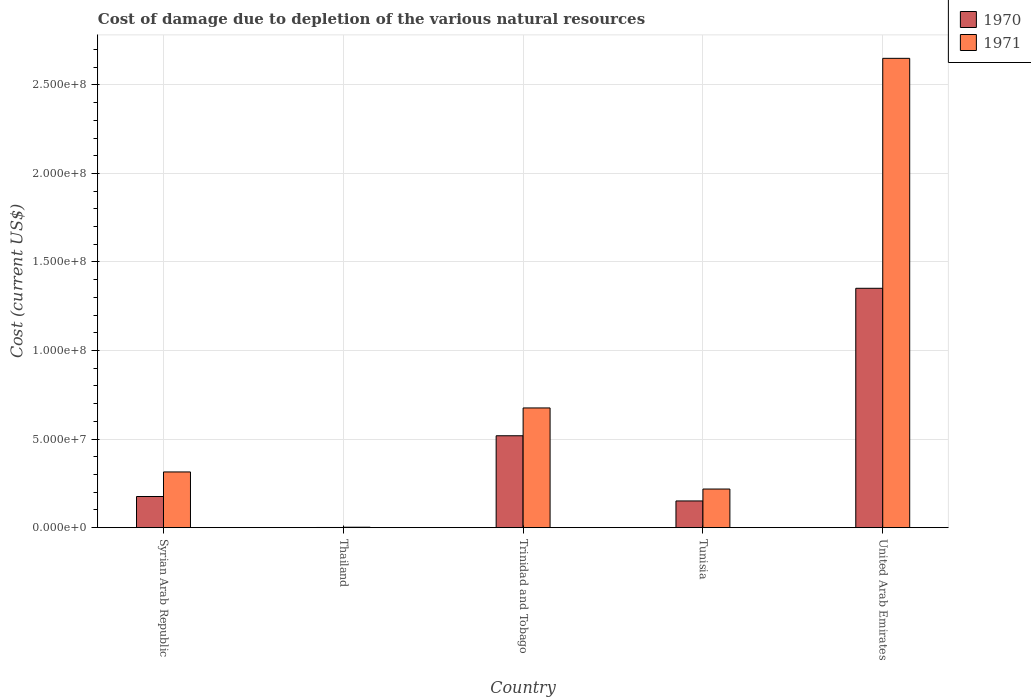How many different coloured bars are there?
Offer a terse response. 2. Are the number of bars per tick equal to the number of legend labels?
Give a very brief answer. Yes. How many bars are there on the 5th tick from the left?
Offer a very short reply. 2. What is the label of the 2nd group of bars from the left?
Make the answer very short. Thailand. What is the cost of damage caused due to the depletion of various natural resources in 1971 in Tunisia?
Offer a very short reply. 2.18e+07. Across all countries, what is the maximum cost of damage caused due to the depletion of various natural resources in 1970?
Provide a succinct answer. 1.35e+08. Across all countries, what is the minimum cost of damage caused due to the depletion of various natural resources in 1971?
Ensure brevity in your answer.  2.43e+05. In which country was the cost of damage caused due to the depletion of various natural resources in 1970 maximum?
Give a very brief answer. United Arab Emirates. In which country was the cost of damage caused due to the depletion of various natural resources in 1971 minimum?
Ensure brevity in your answer.  Thailand. What is the total cost of damage caused due to the depletion of various natural resources in 1971 in the graph?
Provide a succinct answer. 3.86e+08. What is the difference between the cost of damage caused due to the depletion of various natural resources in 1970 in Trinidad and Tobago and that in United Arab Emirates?
Your answer should be compact. -8.33e+07. What is the difference between the cost of damage caused due to the depletion of various natural resources in 1970 in Tunisia and the cost of damage caused due to the depletion of various natural resources in 1971 in United Arab Emirates?
Offer a very short reply. -2.50e+08. What is the average cost of damage caused due to the depletion of various natural resources in 1971 per country?
Your answer should be compact. 7.72e+07. What is the difference between the cost of damage caused due to the depletion of various natural resources of/in 1970 and cost of damage caused due to the depletion of various natural resources of/in 1971 in Tunisia?
Your response must be concise. -6.72e+06. In how many countries, is the cost of damage caused due to the depletion of various natural resources in 1970 greater than 140000000 US$?
Your answer should be very brief. 0. What is the ratio of the cost of damage caused due to the depletion of various natural resources in 1971 in Thailand to that in Tunisia?
Give a very brief answer. 0.01. Is the cost of damage caused due to the depletion of various natural resources in 1970 in Trinidad and Tobago less than that in United Arab Emirates?
Make the answer very short. Yes. Is the difference between the cost of damage caused due to the depletion of various natural resources in 1970 in Trinidad and Tobago and Tunisia greater than the difference between the cost of damage caused due to the depletion of various natural resources in 1971 in Trinidad and Tobago and Tunisia?
Make the answer very short. No. What is the difference between the highest and the second highest cost of damage caused due to the depletion of various natural resources in 1970?
Make the answer very short. -8.33e+07. What is the difference between the highest and the lowest cost of damage caused due to the depletion of various natural resources in 1971?
Your answer should be very brief. 2.65e+08. Is the sum of the cost of damage caused due to the depletion of various natural resources in 1971 in Tunisia and United Arab Emirates greater than the maximum cost of damage caused due to the depletion of various natural resources in 1970 across all countries?
Your answer should be very brief. Yes. What does the 1st bar from the left in United Arab Emirates represents?
Provide a succinct answer. 1970. What is the difference between two consecutive major ticks on the Y-axis?
Offer a very short reply. 5.00e+07. Are the values on the major ticks of Y-axis written in scientific E-notation?
Your response must be concise. Yes. Does the graph contain grids?
Your answer should be very brief. Yes. How many legend labels are there?
Offer a very short reply. 2. How are the legend labels stacked?
Offer a terse response. Vertical. What is the title of the graph?
Provide a succinct answer. Cost of damage due to depletion of the various natural resources. Does "1986" appear as one of the legend labels in the graph?
Provide a short and direct response. No. What is the label or title of the X-axis?
Give a very brief answer. Country. What is the label or title of the Y-axis?
Offer a very short reply. Cost (current US$). What is the Cost (current US$) in 1970 in Syrian Arab Republic?
Your answer should be very brief. 1.76e+07. What is the Cost (current US$) in 1971 in Syrian Arab Republic?
Make the answer very short. 3.14e+07. What is the Cost (current US$) in 1970 in Thailand?
Provide a short and direct response. 9.00e+04. What is the Cost (current US$) in 1971 in Thailand?
Provide a succinct answer. 2.43e+05. What is the Cost (current US$) in 1970 in Trinidad and Tobago?
Your answer should be compact. 5.19e+07. What is the Cost (current US$) in 1971 in Trinidad and Tobago?
Keep it short and to the point. 6.76e+07. What is the Cost (current US$) of 1970 in Tunisia?
Your answer should be compact. 1.51e+07. What is the Cost (current US$) of 1971 in Tunisia?
Keep it short and to the point. 2.18e+07. What is the Cost (current US$) in 1970 in United Arab Emirates?
Give a very brief answer. 1.35e+08. What is the Cost (current US$) in 1971 in United Arab Emirates?
Offer a very short reply. 2.65e+08. Across all countries, what is the maximum Cost (current US$) in 1970?
Your response must be concise. 1.35e+08. Across all countries, what is the maximum Cost (current US$) in 1971?
Ensure brevity in your answer.  2.65e+08. Across all countries, what is the minimum Cost (current US$) of 1970?
Offer a very short reply. 9.00e+04. Across all countries, what is the minimum Cost (current US$) of 1971?
Offer a terse response. 2.43e+05. What is the total Cost (current US$) of 1970 in the graph?
Provide a short and direct response. 2.20e+08. What is the total Cost (current US$) in 1971 in the graph?
Make the answer very short. 3.86e+08. What is the difference between the Cost (current US$) of 1970 in Syrian Arab Republic and that in Thailand?
Make the answer very short. 1.75e+07. What is the difference between the Cost (current US$) of 1971 in Syrian Arab Republic and that in Thailand?
Provide a succinct answer. 3.12e+07. What is the difference between the Cost (current US$) in 1970 in Syrian Arab Republic and that in Trinidad and Tobago?
Your response must be concise. -3.43e+07. What is the difference between the Cost (current US$) in 1971 in Syrian Arab Republic and that in Trinidad and Tobago?
Make the answer very short. -3.61e+07. What is the difference between the Cost (current US$) in 1970 in Syrian Arab Republic and that in Tunisia?
Your answer should be very brief. 2.51e+06. What is the difference between the Cost (current US$) in 1971 in Syrian Arab Republic and that in Tunisia?
Offer a terse response. 9.65e+06. What is the difference between the Cost (current US$) of 1970 in Syrian Arab Republic and that in United Arab Emirates?
Ensure brevity in your answer.  -1.18e+08. What is the difference between the Cost (current US$) in 1971 in Syrian Arab Republic and that in United Arab Emirates?
Make the answer very short. -2.34e+08. What is the difference between the Cost (current US$) in 1970 in Thailand and that in Trinidad and Tobago?
Give a very brief answer. -5.18e+07. What is the difference between the Cost (current US$) of 1971 in Thailand and that in Trinidad and Tobago?
Give a very brief answer. -6.73e+07. What is the difference between the Cost (current US$) in 1970 in Thailand and that in Tunisia?
Give a very brief answer. -1.50e+07. What is the difference between the Cost (current US$) of 1971 in Thailand and that in Tunisia?
Give a very brief answer. -2.16e+07. What is the difference between the Cost (current US$) in 1970 in Thailand and that in United Arab Emirates?
Your answer should be compact. -1.35e+08. What is the difference between the Cost (current US$) in 1971 in Thailand and that in United Arab Emirates?
Provide a short and direct response. -2.65e+08. What is the difference between the Cost (current US$) in 1970 in Trinidad and Tobago and that in Tunisia?
Ensure brevity in your answer.  3.68e+07. What is the difference between the Cost (current US$) in 1971 in Trinidad and Tobago and that in Tunisia?
Offer a very short reply. 4.58e+07. What is the difference between the Cost (current US$) in 1970 in Trinidad and Tobago and that in United Arab Emirates?
Offer a very short reply. -8.33e+07. What is the difference between the Cost (current US$) of 1971 in Trinidad and Tobago and that in United Arab Emirates?
Your answer should be very brief. -1.97e+08. What is the difference between the Cost (current US$) of 1970 in Tunisia and that in United Arab Emirates?
Keep it short and to the point. -1.20e+08. What is the difference between the Cost (current US$) of 1971 in Tunisia and that in United Arab Emirates?
Your response must be concise. -2.43e+08. What is the difference between the Cost (current US$) of 1970 in Syrian Arab Republic and the Cost (current US$) of 1971 in Thailand?
Provide a short and direct response. 1.73e+07. What is the difference between the Cost (current US$) in 1970 in Syrian Arab Republic and the Cost (current US$) in 1971 in Trinidad and Tobago?
Make the answer very short. -5.00e+07. What is the difference between the Cost (current US$) in 1970 in Syrian Arab Republic and the Cost (current US$) in 1971 in Tunisia?
Ensure brevity in your answer.  -4.21e+06. What is the difference between the Cost (current US$) in 1970 in Syrian Arab Republic and the Cost (current US$) in 1971 in United Arab Emirates?
Your response must be concise. -2.47e+08. What is the difference between the Cost (current US$) in 1970 in Thailand and the Cost (current US$) in 1971 in Trinidad and Tobago?
Give a very brief answer. -6.75e+07. What is the difference between the Cost (current US$) of 1970 in Thailand and the Cost (current US$) of 1971 in Tunisia?
Offer a very short reply. -2.17e+07. What is the difference between the Cost (current US$) in 1970 in Thailand and the Cost (current US$) in 1971 in United Arab Emirates?
Ensure brevity in your answer.  -2.65e+08. What is the difference between the Cost (current US$) in 1970 in Trinidad and Tobago and the Cost (current US$) in 1971 in Tunisia?
Your response must be concise. 3.01e+07. What is the difference between the Cost (current US$) in 1970 in Trinidad and Tobago and the Cost (current US$) in 1971 in United Arab Emirates?
Your answer should be compact. -2.13e+08. What is the difference between the Cost (current US$) of 1970 in Tunisia and the Cost (current US$) of 1971 in United Arab Emirates?
Offer a terse response. -2.50e+08. What is the average Cost (current US$) in 1970 per country?
Your response must be concise. 4.40e+07. What is the average Cost (current US$) in 1971 per country?
Your answer should be very brief. 7.72e+07. What is the difference between the Cost (current US$) of 1970 and Cost (current US$) of 1971 in Syrian Arab Republic?
Keep it short and to the point. -1.39e+07. What is the difference between the Cost (current US$) in 1970 and Cost (current US$) in 1971 in Thailand?
Offer a terse response. -1.53e+05. What is the difference between the Cost (current US$) in 1970 and Cost (current US$) in 1971 in Trinidad and Tobago?
Your answer should be compact. -1.57e+07. What is the difference between the Cost (current US$) of 1970 and Cost (current US$) of 1971 in Tunisia?
Offer a very short reply. -6.72e+06. What is the difference between the Cost (current US$) in 1970 and Cost (current US$) in 1971 in United Arab Emirates?
Provide a succinct answer. -1.30e+08. What is the ratio of the Cost (current US$) in 1970 in Syrian Arab Republic to that in Thailand?
Ensure brevity in your answer.  195.44. What is the ratio of the Cost (current US$) in 1971 in Syrian Arab Republic to that in Thailand?
Make the answer very short. 129.33. What is the ratio of the Cost (current US$) of 1970 in Syrian Arab Republic to that in Trinidad and Tobago?
Provide a succinct answer. 0.34. What is the ratio of the Cost (current US$) of 1971 in Syrian Arab Republic to that in Trinidad and Tobago?
Provide a short and direct response. 0.47. What is the ratio of the Cost (current US$) of 1970 in Syrian Arab Republic to that in Tunisia?
Offer a very short reply. 1.17. What is the ratio of the Cost (current US$) in 1971 in Syrian Arab Republic to that in Tunisia?
Your answer should be compact. 1.44. What is the ratio of the Cost (current US$) of 1970 in Syrian Arab Republic to that in United Arab Emirates?
Give a very brief answer. 0.13. What is the ratio of the Cost (current US$) of 1971 in Syrian Arab Republic to that in United Arab Emirates?
Provide a succinct answer. 0.12. What is the ratio of the Cost (current US$) in 1970 in Thailand to that in Trinidad and Tobago?
Give a very brief answer. 0. What is the ratio of the Cost (current US$) in 1971 in Thailand to that in Trinidad and Tobago?
Your answer should be very brief. 0. What is the ratio of the Cost (current US$) of 1970 in Thailand to that in Tunisia?
Offer a terse response. 0.01. What is the ratio of the Cost (current US$) of 1971 in Thailand to that in Tunisia?
Ensure brevity in your answer.  0.01. What is the ratio of the Cost (current US$) in 1970 in Thailand to that in United Arab Emirates?
Provide a succinct answer. 0. What is the ratio of the Cost (current US$) of 1971 in Thailand to that in United Arab Emirates?
Provide a short and direct response. 0. What is the ratio of the Cost (current US$) in 1970 in Trinidad and Tobago to that in Tunisia?
Provide a short and direct response. 3.44. What is the ratio of the Cost (current US$) of 1971 in Trinidad and Tobago to that in Tunisia?
Offer a terse response. 3.1. What is the ratio of the Cost (current US$) of 1970 in Trinidad and Tobago to that in United Arab Emirates?
Offer a very short reply. 0.38. What is the ratio of the Cost (current US$) in 1971 in Trinidad and Tobago to that in United Arab Emirates?
Your response must be concise. 0.26. What is the ratio of the Cost (current US$) of 1970 in Tunisia to that in United Arab Emirates?
Make the answer very short. 0.11. What is the ratio of the Cost (current US$) in 1971 in Tunisia to that in United Arab Emirates?
Give a very brief answer. 0.08. What is the difference between the highest and the second highest Cost (current US$) in 1970?
Provide a short and direct response. 8.33e+07. What is the difference between the highest and the second highest Cost (current US$) of 1971?
Offer a terse response. 1.97e+08. What is the difference between the highest and the lowest Cost (current US$) of 1970?
Offer a very short reply. 1.35e+08. What is the difference between the highest and the lowest Cost (current US$) of 1971?
Your answer should be very brief. 2.65e+08. 